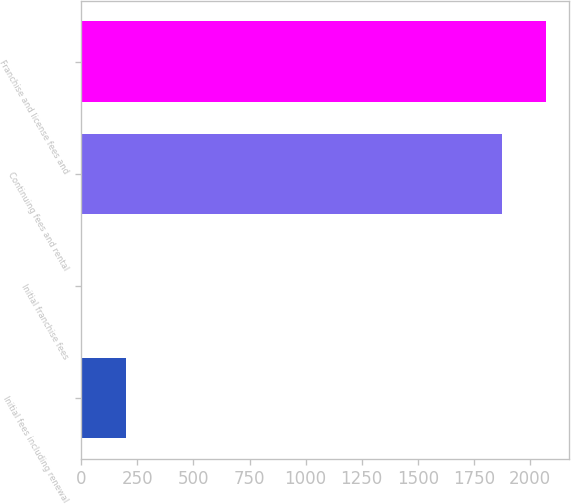<chart> <loc_0><loc_0><loc_500><loc_500><bar_chart><fcel>Initial fees including renewal<fcel>Initial franchise fees<fcel>Continuing fees and rental<fcel>Franchise and license fees and<nl><fcel>200<fcel>5<fcel>1877<fcel>2072<nl></chart> 